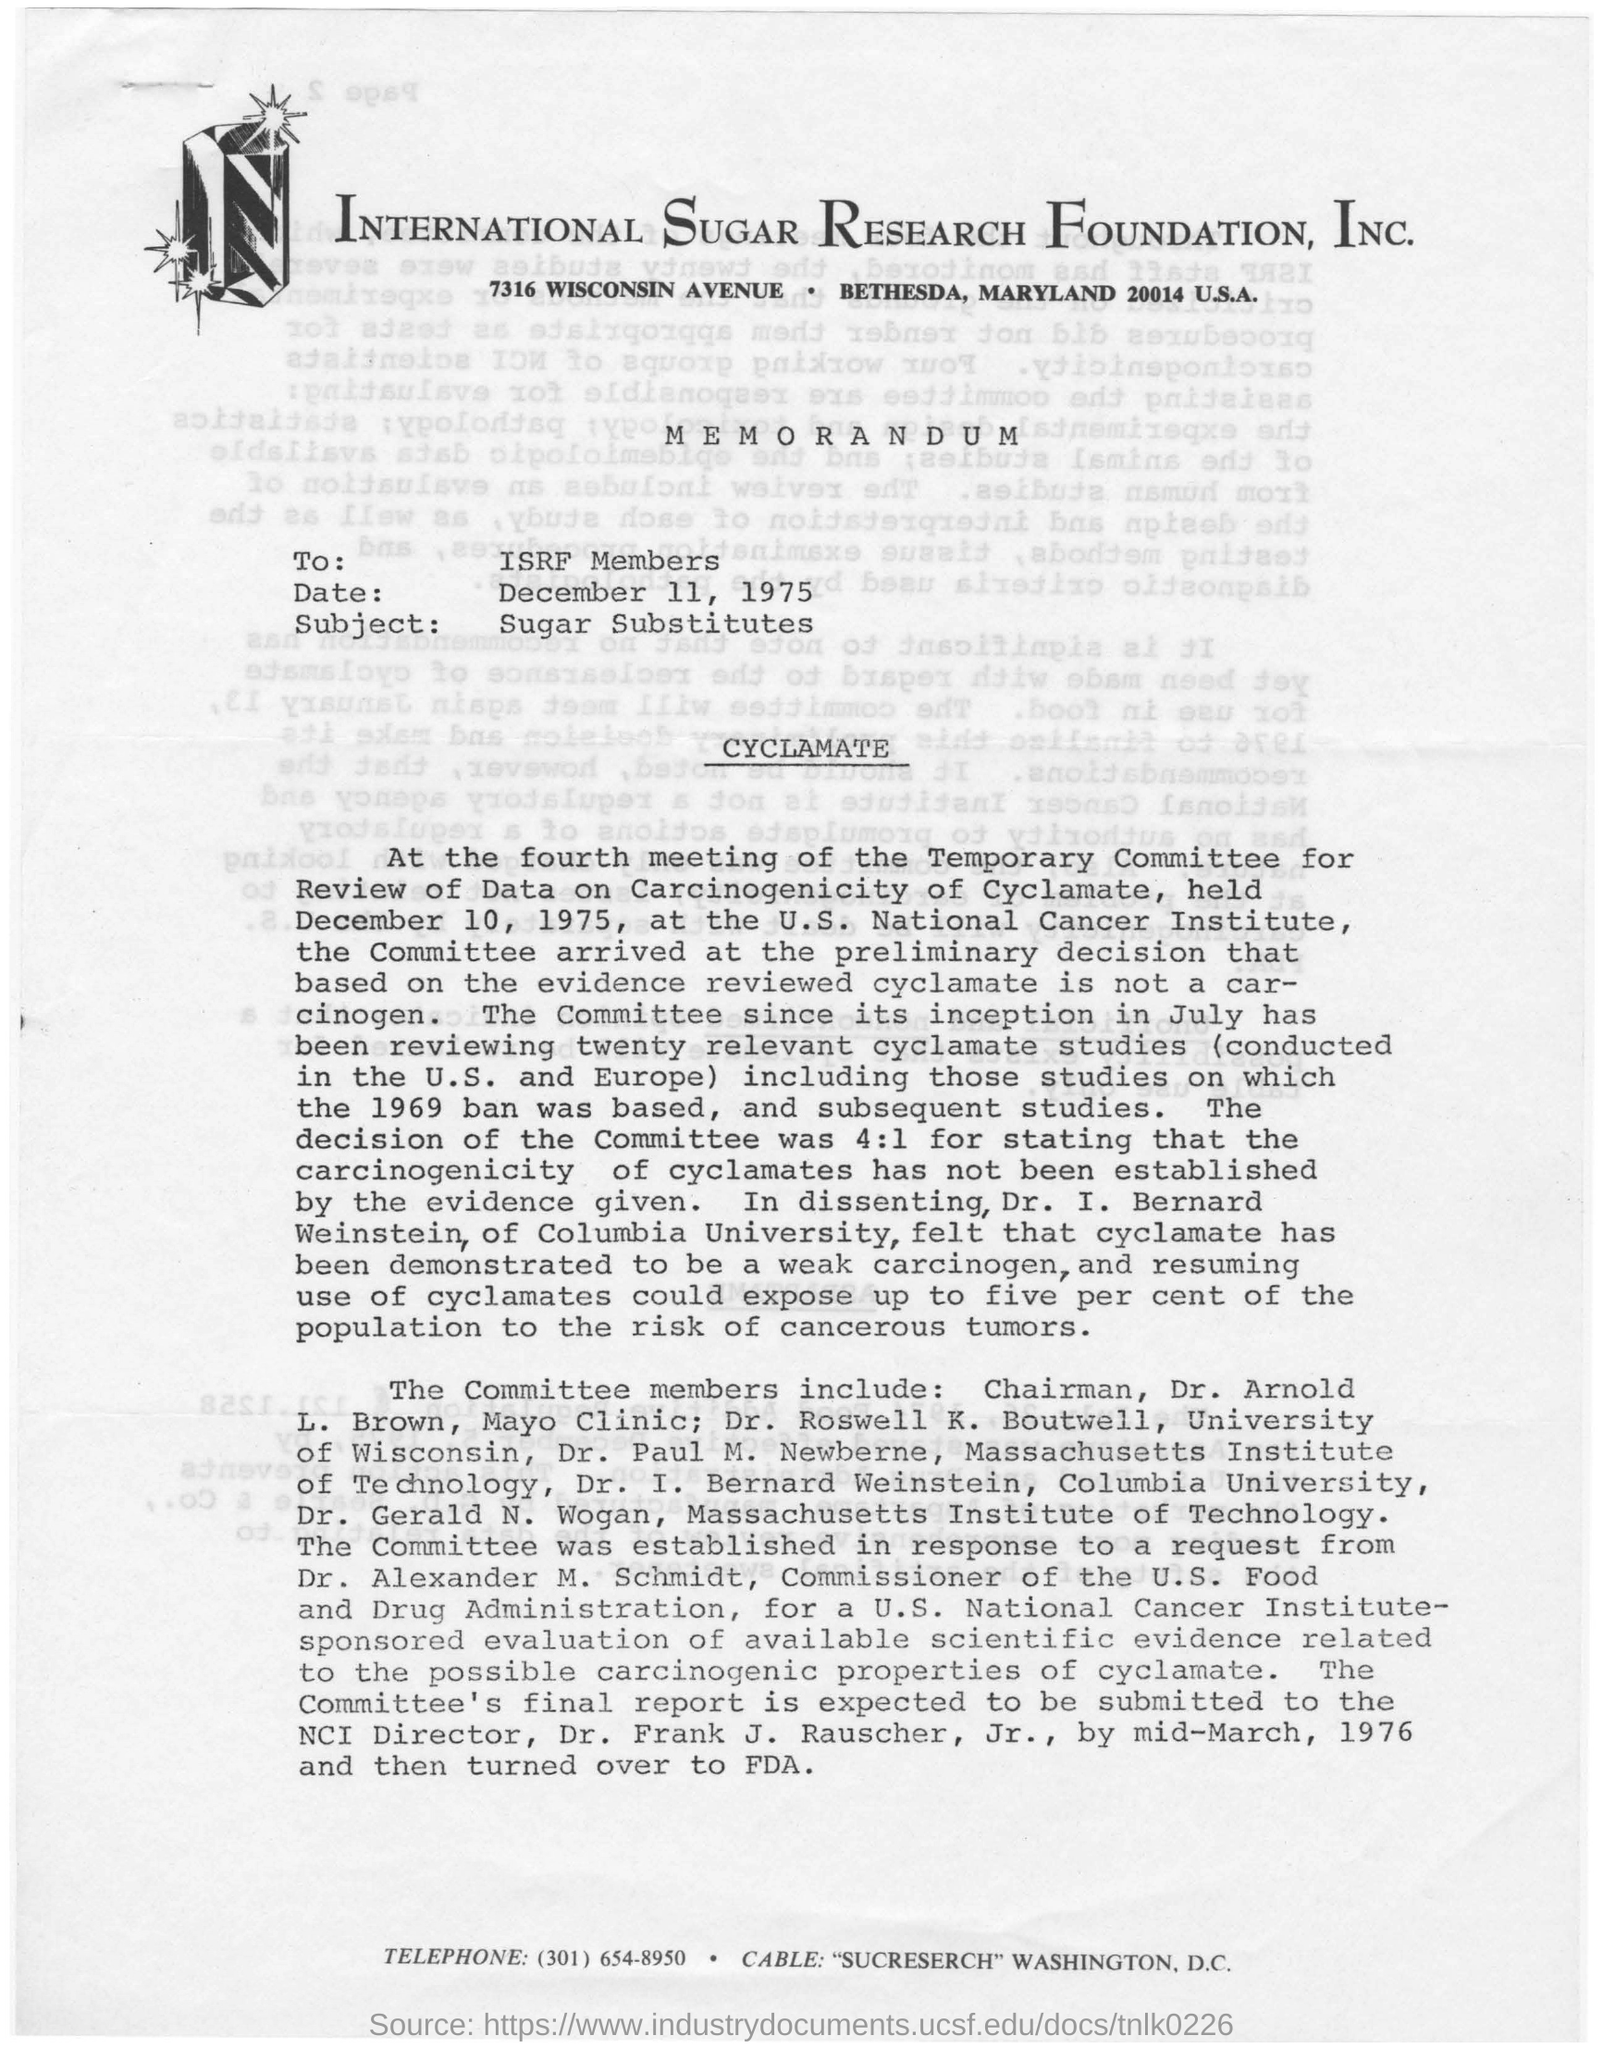Outline some significant characteristics in this image. The International Sugar Research Foundation is the name of the foundation mentioned. The avenue mentioned is named Wisconsin Avenue. The date mentioned in the given page is December 11, 1975. The subject mentioned is sugar substitutes. The memorandum was written to the ISRF Members. 